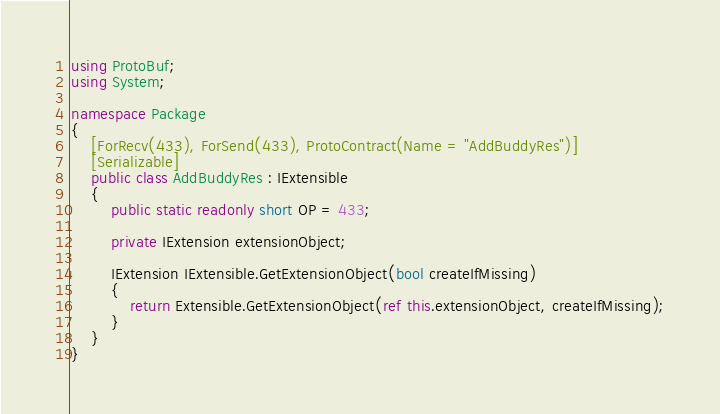Convert code to text. <code><loc_0><loc_0><loc_500><loc_500><_C#_>using ProtoBuf;
using System;

namespace Package
{
	[ForRecv(433), ForSend(433), ProtoContract(Name = "AddBuddyRes")]
	[Serializable]
	public class AddBuddyRes : IExtensible
	{
		public static readonly short OP = 433;

		private IExtension extensionObject;

		IExtension IExtensible.GetExtensionObject(bool createIfMissing)
		{
			return Extensible.GetExtensionObject(ref this.extensionObject, createIfMissing);
		}
	}
}
</code> 